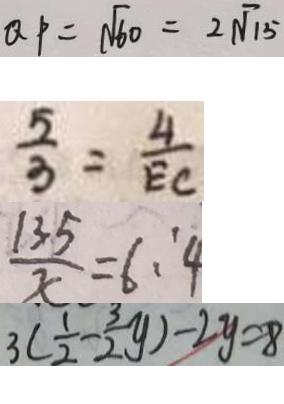Convert formula to latex. <formula><loc_0><loc_0><loc_500><loc_500>Q P = \sqrt { 6 0 } = 2 \sqrt { 1 5 } 
 \frac { 5 } { 3 } = \frac { 4 } { E C } 
 \frac { 1 3 5 } { x } = 6 : 4 
 3 ( \frac { 1 } { 2 } - \frac { 3 } { 2 } y ) - 2 y = 8</formula> 